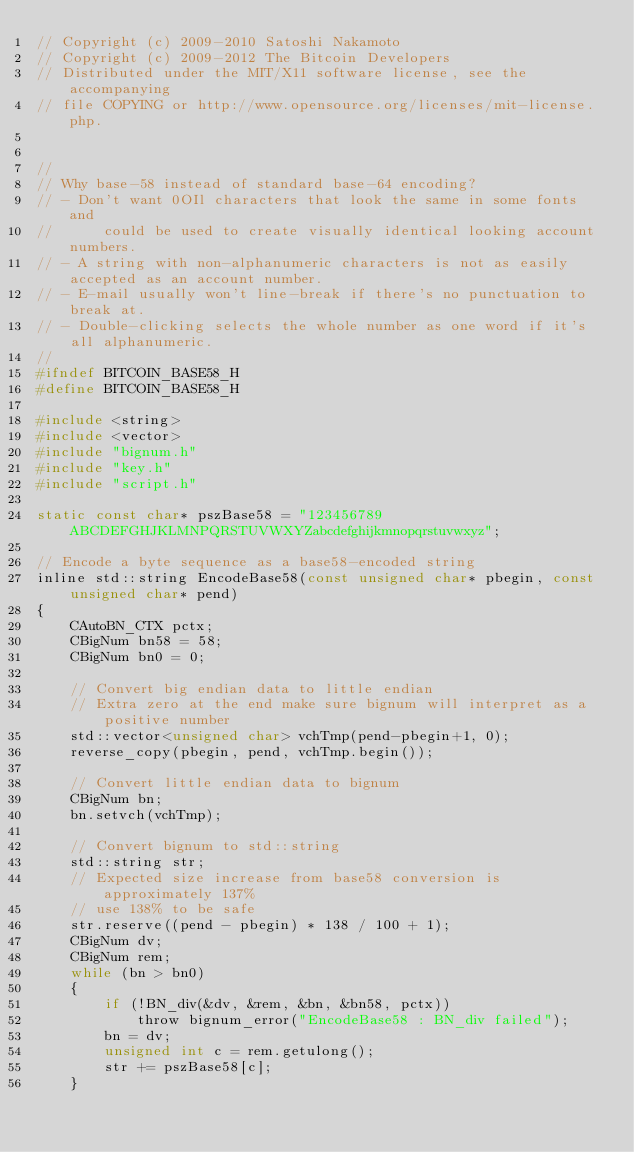<code> <loc_0><loc_0><loc_500><loc_500><_C_>// Copyright (c) 2009-2010 Satoshi Nakamoto
// Copyright (c) 2009-2012 The Bitcoin Developers
// Distributed under the MIT/X11 software license, see the accompanying
// file COPYING or http://www.opensource.org/licenses/mit-license.php.


//
// Why base-58 instead of standard base-64 encoding?
// - Don't want 0OIl characters that look the same in some fonts and
//      could be used to create visually identical looking account numbers.
// - A string with non-alphanumeric characters is not as easily accepted as an account number.
// - E-mail usually won't line-break if there's no punctuation to break at.
// - Double-clicking selects the whole number as one word if it's all alphanumeric.
//
#ifndef BITCOIN_BASE58_H
#define BITCOIN_BASE58_H

#include <string>
#include <vector>
#include "bignum.h"
#include "key.h"
#include "script.h"

static const char* pszBase58 = "123456789ABCDEFGHJKLMNPQRSTUVWXYZabcdefghijkmnopqrstuvwxyz";

// Encode a byte sequence as a base58-encoded string
inline std::string EncodeBase58(const unsigned char* pbegin, const unsigned char* pend)
{
    CAutoBN_CTX pctx;
    CBigNum bn58 = 58;
    CBigNum bn0 = 0;

    // Convert big endian data to little endian
    // Extra zero at the end make sure bignum will interpret as a positive number
    std::vector<unsigned char> vchTmp(pend-pbegin+1, 0);
    reverse_copy(pbegin, pend, vchTmp.begin());

    // Convert little endian data to bignum
    CBigNum bn;
    bn.setvch(vchTmp);

    // Convert bignum to std::string
    std::string str;
    // Expected size increase from base58 conversion is approximately 137%
    // use 138% to be safe
    str.reserve((pend - pbegin) * 138 / 100 + 1);
    CBigNum dv;
    CBigNum rem;
    while (bn > bn0)
    {
        if (!BN_div(&dv, &rem, &bn, &bn58, pctx))
            throw bignum_error("EncodeBase58 : BN_div failed");
        bn = dv;
        unsigned int c = rem.getulong();
        str += pszBase58[c];
    }
</code> 